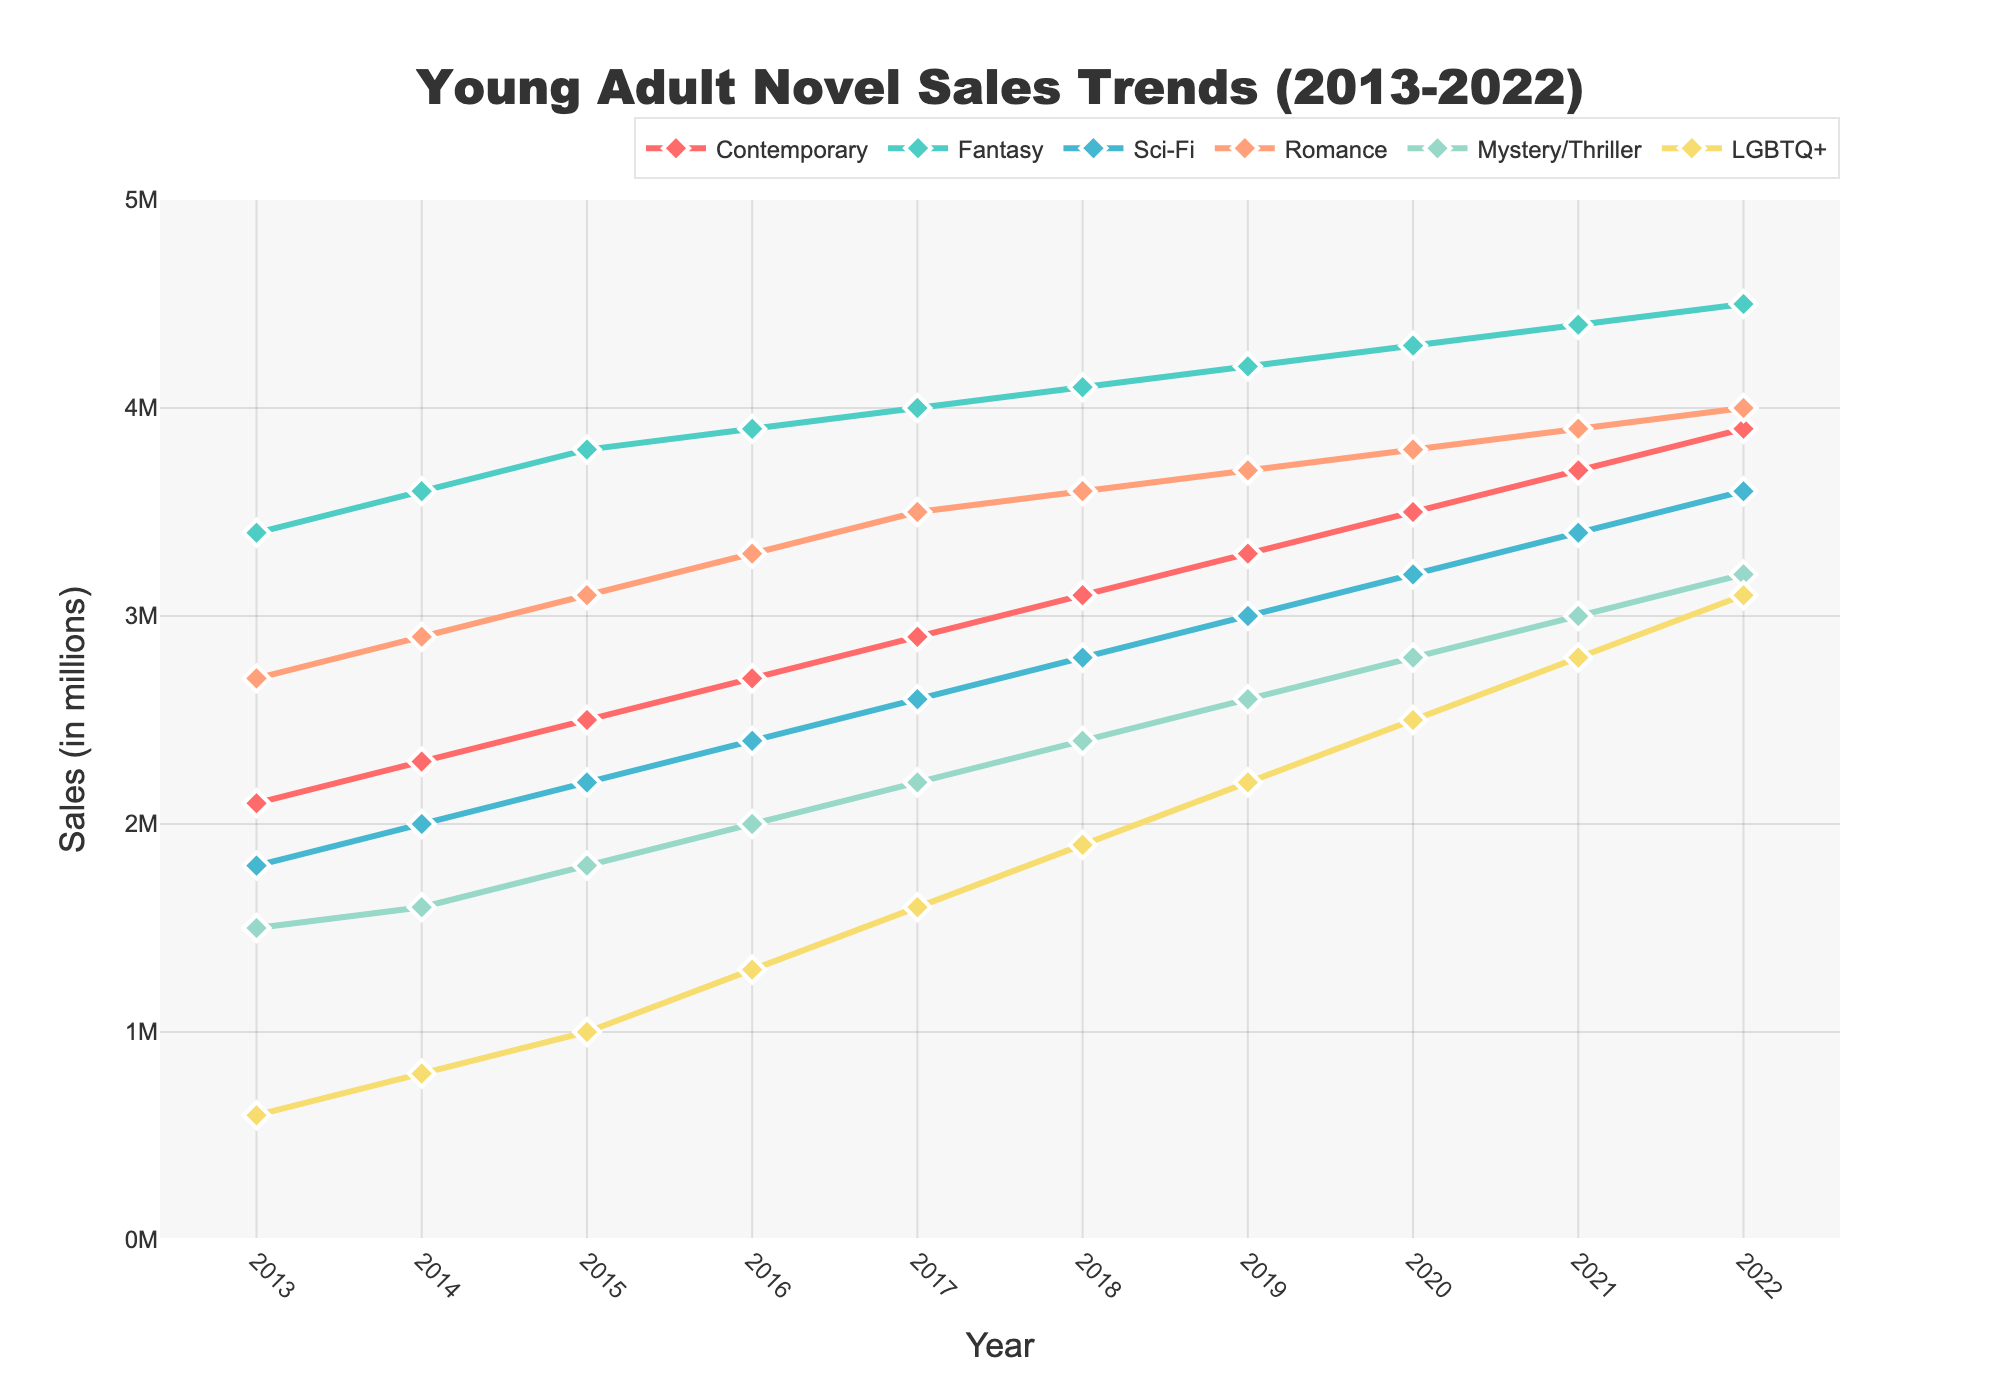Which subgenre had the highest sales figure in 2022? Look for the subgenre with the highest data point in 2022. Fantasy shows the highest sales figure with 4.5 million.
Answer: Fantasy What is the difference in sales between Fantasy and Romance in 2020? In 2020, Fantasy sales were 4.3 million, and Romance sales were 3.8 million. The difference is 4.3 - 3.8 = 0.5 million.
Answer: 0.5 million Which subgenre had the smallest increase in sales from 2013 to 2022? Calculate the increase for each subgenre from 2013 to 2022. Contemporary: 3.9 - 2.1 = 1.8, Fantasy: 4.5 - 3.4 = 1.1, Sci-Fi: 3.6 - 1.8 = 1.8, Romance: 4.0 - 2.7 = 1.3, Mystery/Thriller: 3.2 - 1.5 = 1.7, LGBTQ+: 3.1 - 0.6 = 2.5. Fantasy has the smallest increase with 1.1 million.
Answer: Fantasy Which subgenre had the steadiest growth trend across the decade? Look for the subgenre with the most consistently increasing values. Fantasy shows consistent growth across the decade with small increments.
Answer: Fantasy By how much did the sales of LGBTQ+ novels grow from 2016 to 2022? In 2016, LGBTQ+ sales were 1.3 million. By 2022, the sales increased to 3.1 million. The growth is 3.1 - 1.3 = 1.8 million.
Answer: 1.8 million In which year did the Mystery/Thriller subgenre surpass the 2 million sales mark? Check the sales figures for Mystery/Thriller across the years. In 2017, it reached 2.2 million, which surpasses the 2 million mark.
Answer: 2017 Which two subgenres had equal sales in any given year? Compare the sales figures for each pair of subgenres each year. In 2017, Contemporary and Sci-Fi both had sales of 2.6 million.
Answer: Contemporary and Sci-Fi in 2017 How did the sales of Sci-Fi novels compare to Romance novels in 2019? Check the sales figures for both subgenres in 2019. Sci-Fi had 3.0 million, and Romance had 3.7 million sales. Sci-Fi sales are less than Romance sales.
Answer: Sci-Fi < Romance What is the average annual growth of the Contemporary subgenre from 2013 to 2022? Calculate the increase over the period, then divide by the number of years. Increase: 3.9 - 2.1 = 1.8 million. Average annual growth: 1.8 / 9 = 0.2 million per year.
Answer: 0.2 million per year Which subgenre exhibited the most sporadic growth patterns in the given period? Look for the subgenre with the least consistent growth and noticeable jumps. LGBTQ+ shows the most sporadic growth with varying rates of increase.
Answer: LGBTQ+ 